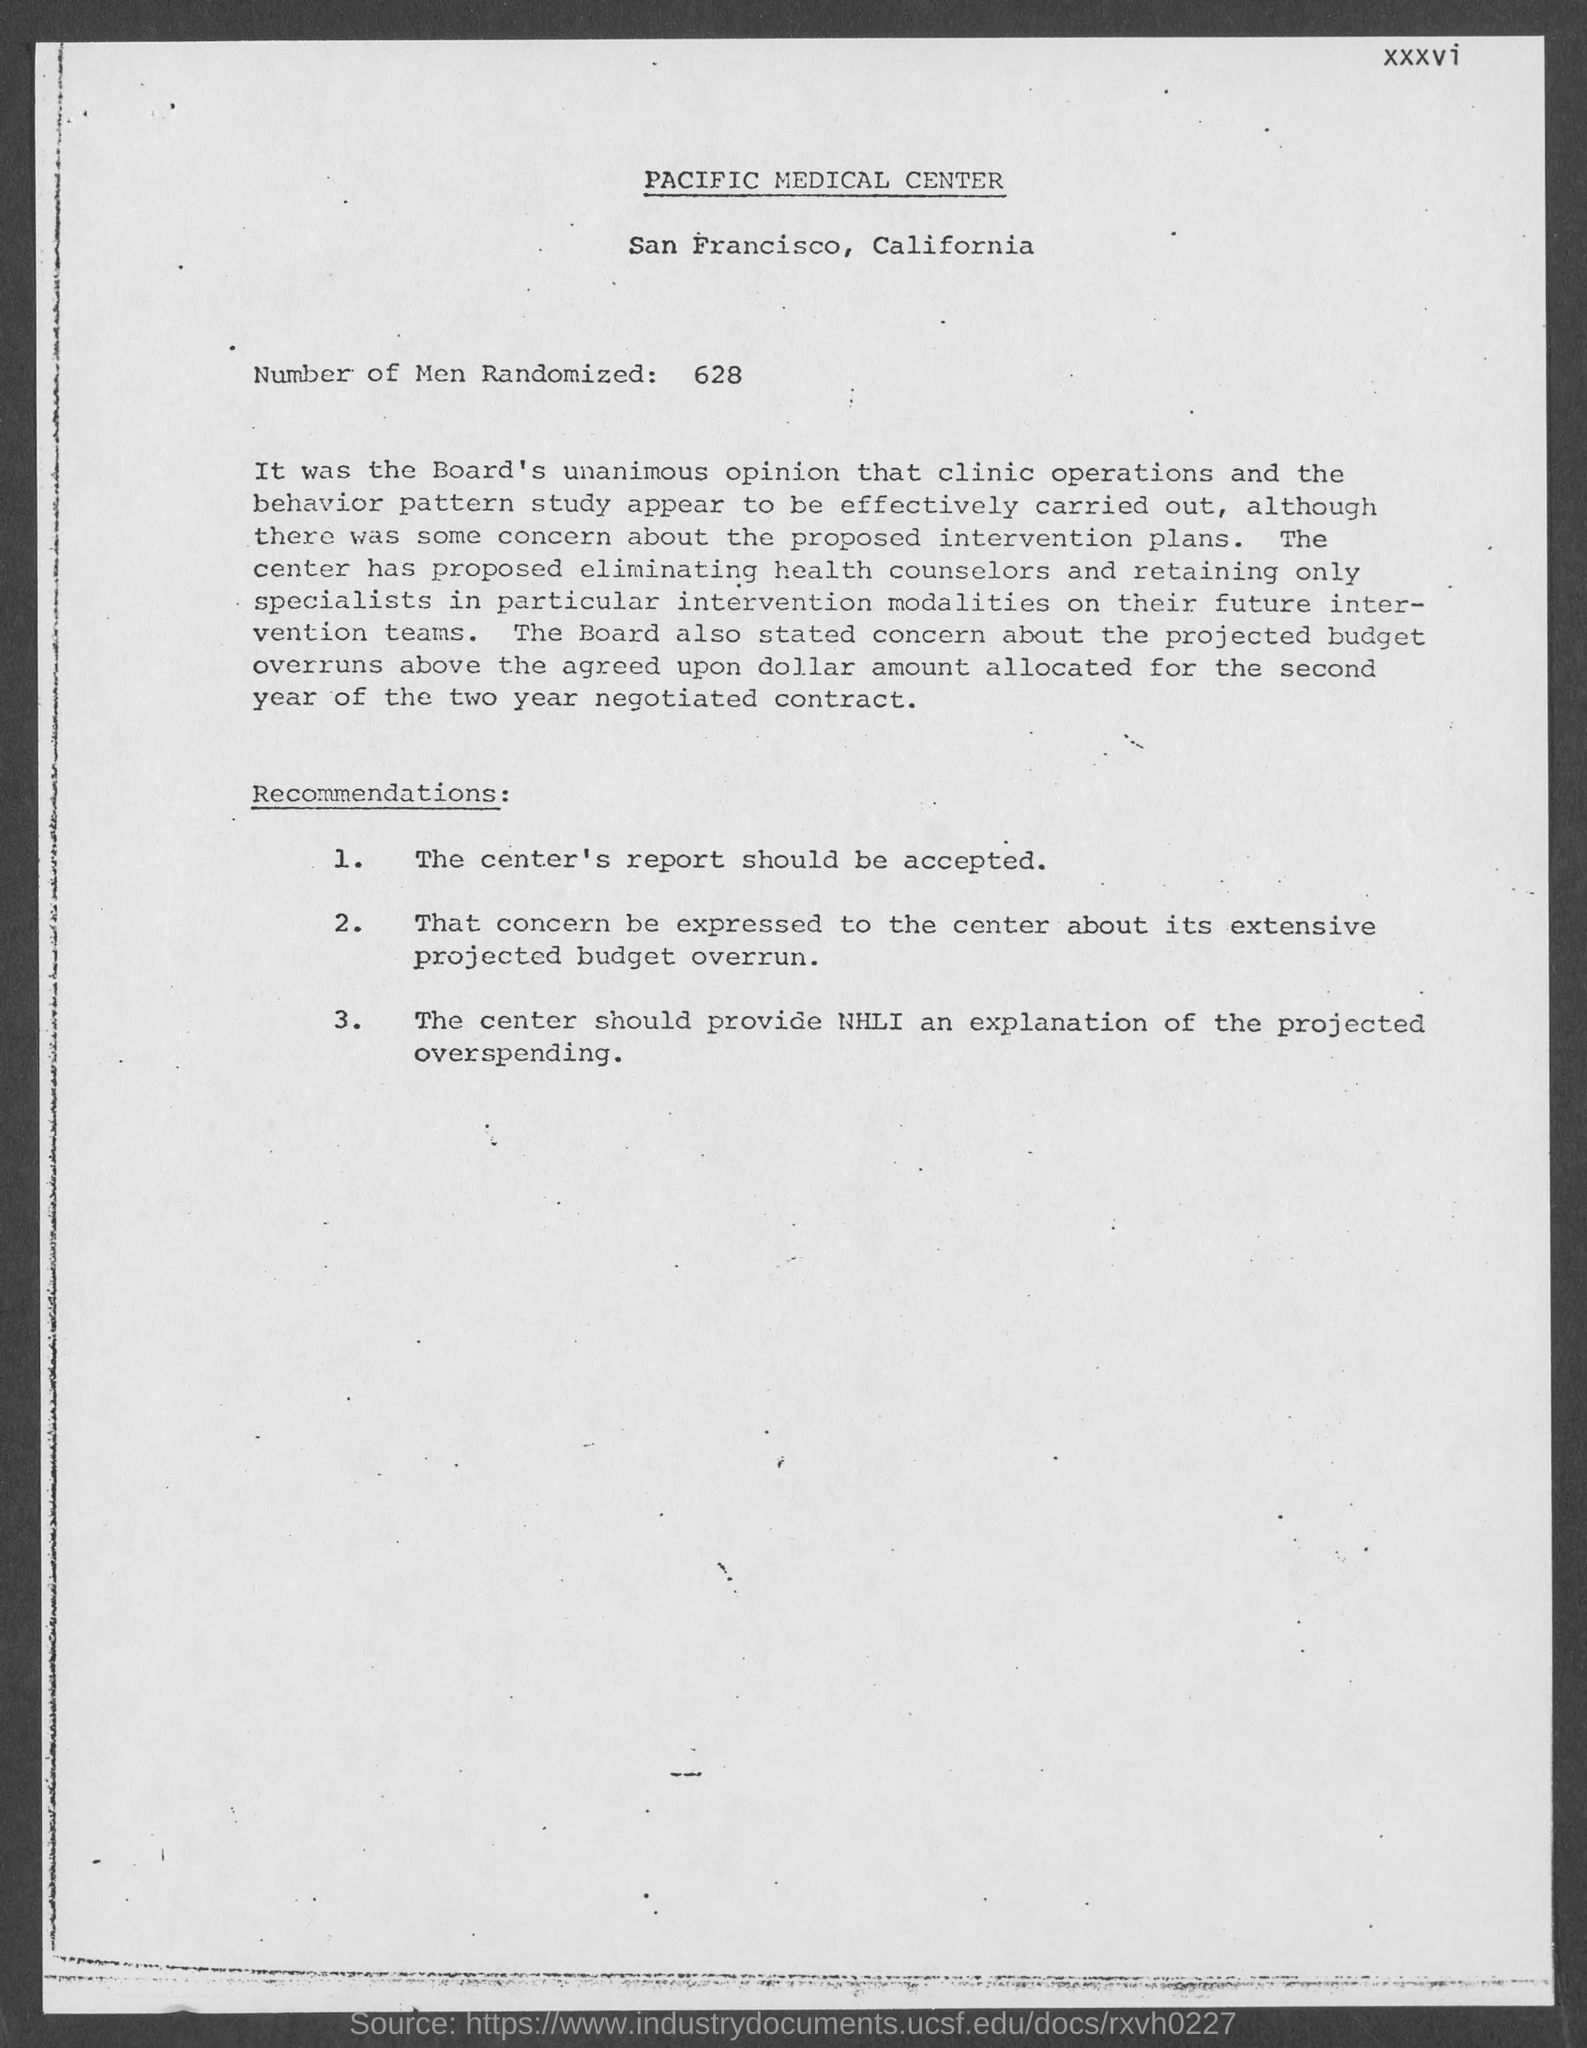List a handful of essential elements in this visual. How many men were randomly selected? 628 were selected. 